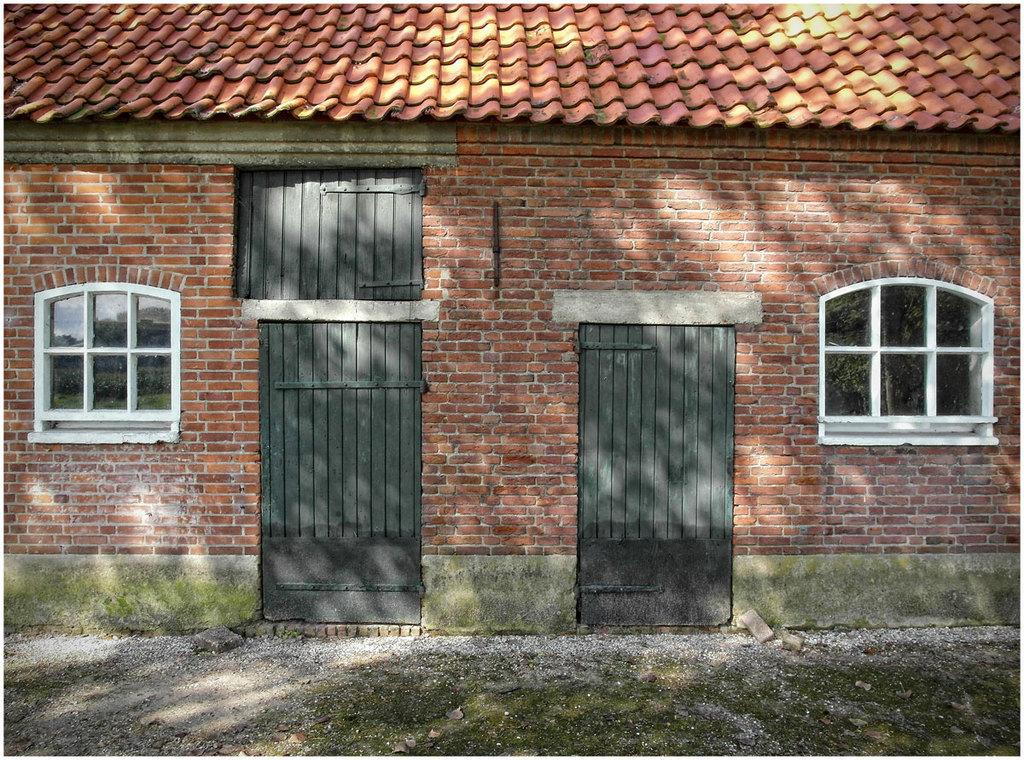What type of structure is present in the image? There is a building in the image. What is the color of the building? The building is red in color. What are the main features of the building? The building has doors and windows. Can you see any cracks in the building's skirt in the image? There is no skirt present on the building in the image, and therefore no cracks can be observed. 